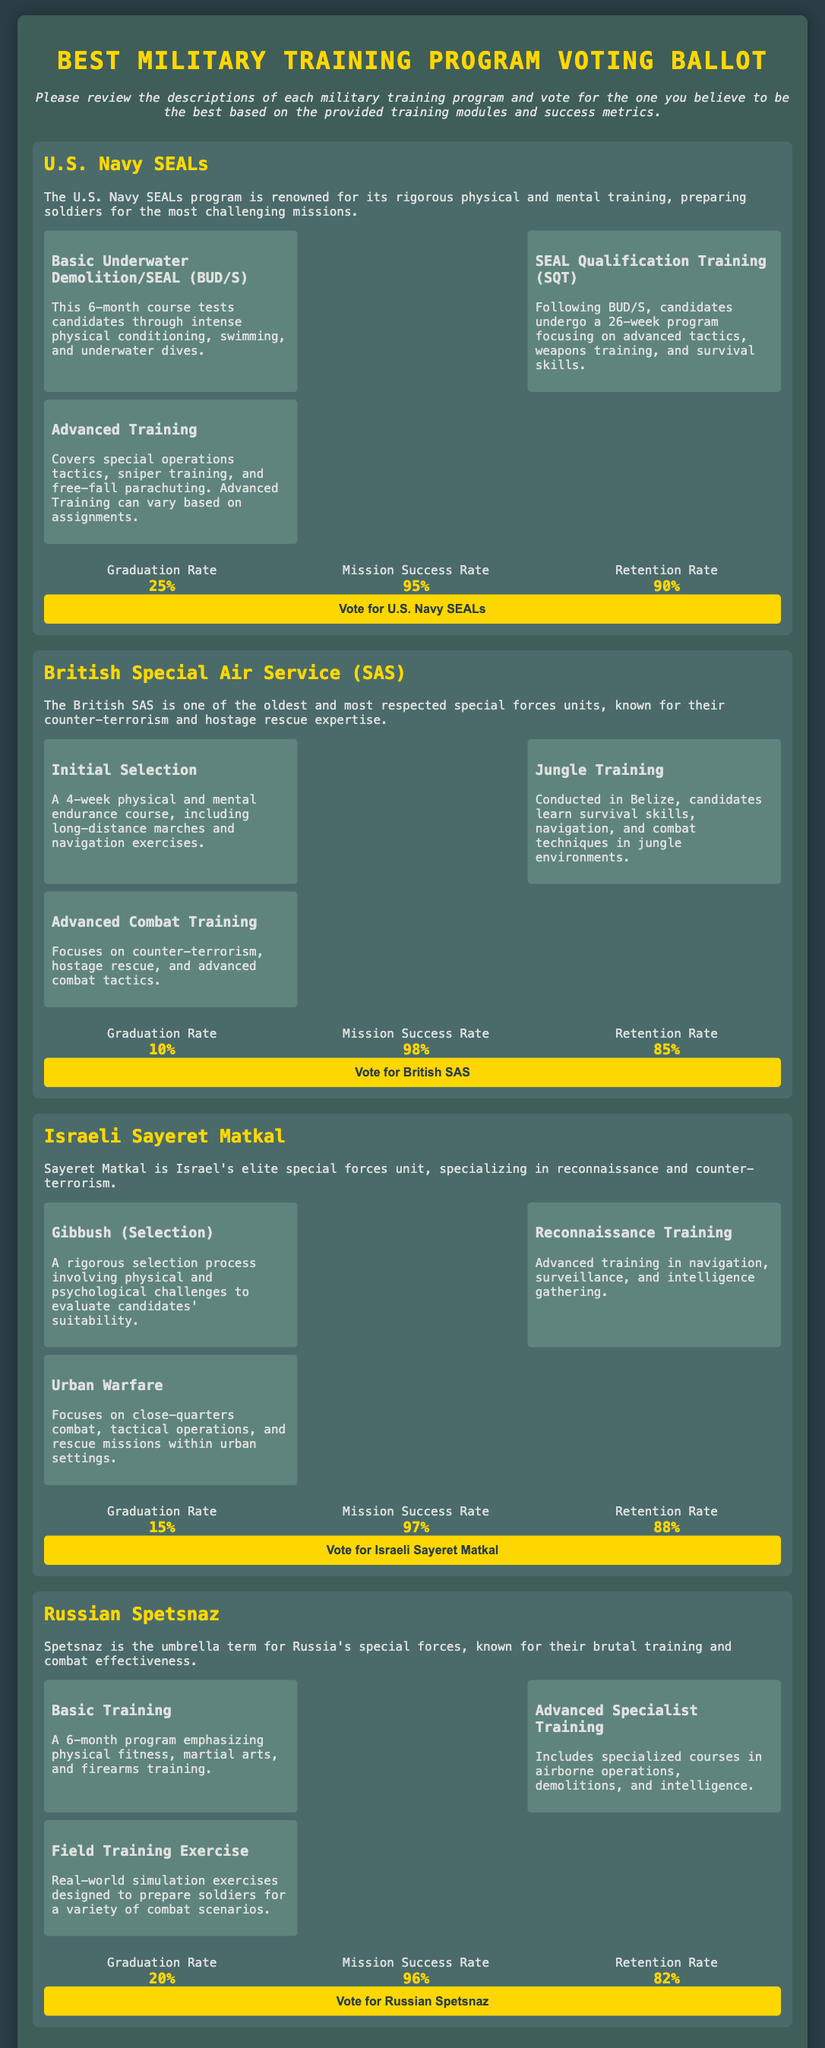what is the graduation rate for U.S. Navy SEALs? The graduation rate for U.S. Navy SEALs is listed as 25%.
Answer: 25% what training module follows BUD/S in the U.S. Navy SEALs program? The module that follows BUD/S is the SEAL Qualification Training (SQT).
Answer: SEAL Qualification Training (SQT) which program has the highest mission success rate? The question requires comparing mission success rates across programs; the British SAS has the highest at 98%.
Answer: British SAS how long is the Advanced Training module in the U.S. Navy SEALs program? The Advanced Training module can vary based on assignments, implying it doesn't have a fixed duration.
Answer: Varies which military program has the lowest graduation rate? The document states that the British SAS has the lowest graduation rate at 10%.
Answer: 10% what is a key focus in the Jungle Training module of the British SAS? The Jungle Training module focuses on survival skills, navigation, and combat techniques.
Answer: Survival skills, navigation, combat techniques how many training modules does the Israeli Sayeret Matkal include? The document lists three training modules for the Israeli Sayeret Matkal program.
Answer: Three which military training program includes a Field Training Exercise? The Field Training Exercise is part of the Russian Spetsnaz training program.
Answer: Russian Spetsnaz 